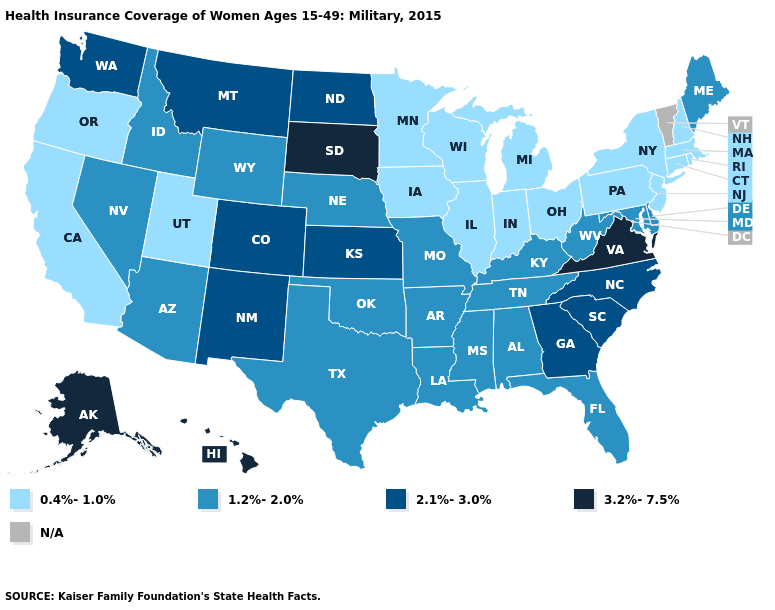What is the highest value in states that border New Jersey?
Short answer required. 1.2%-2.0%. Is the legend a continuous bar?
Keep it brief. No. Is the legend a continuous bar?
Concise answer only. No. Does Maine have the highest value in the Northeast?
Write a very short answer. Yes. Which states have the lowest value in the USA?
Answer briefly. California, Connecticut, Illinois, Indiana, Iowa, Massachusetts, Michigan, Minnesota, New Hampshire, New Jersey, New York, Ohio, Oregon, Pennsylvania, Rhode Island, Utah, Wisconsin. What is the value of Wisconsin?
Quick response, please. 0.4%-1.0%. Among the states that border Texas , which have the highest value?
Concise answer only. New Mexico. Which states have the highest value in the USA?
Answer briefly. Alaska, Hawaii, South Dakota, Virginia. What is the highest value in the USA?
Give a very brief answer. 3.2%-7.5%. What is the lowest value in the USA?
Write a very short answer. 0.4%-1.0%. What is the value of Louisiana?
Give a very brief answer. 1.2%-2.0%. Does the first symbol in the legend represent the smallest category?
Answer briefly. Yes. What is the value of Indiana?
Keep it brief. 0.4%-1.0%. What is the highest value in states that border Virginia?
Keep it brief. 2.1%-3.0%. What is the highest value in states that border Indiana?
Write a very short answer. 1.2%-2.0%. 